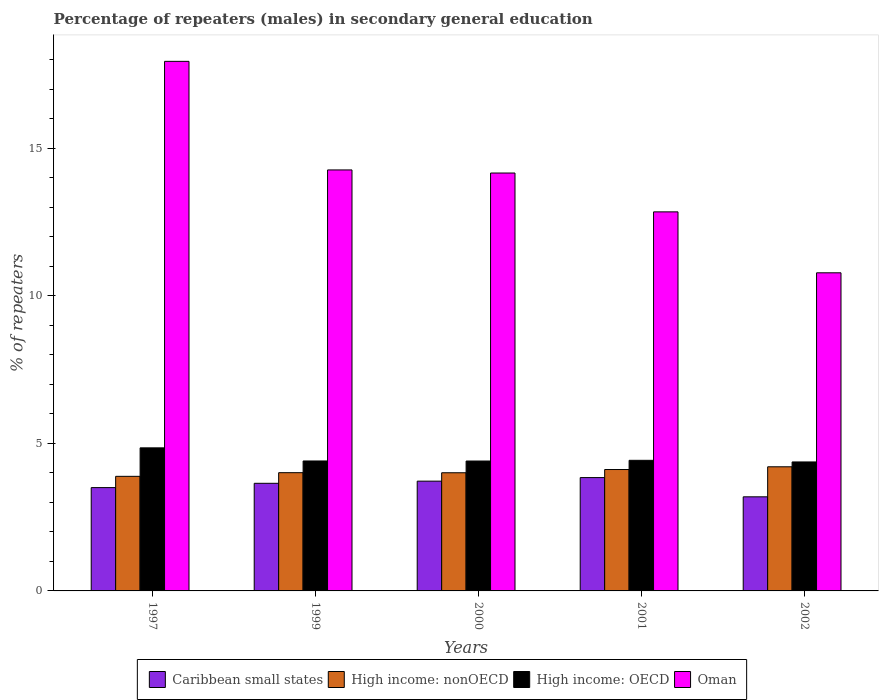How many groups of bars are there?
Your response must be concise. 5. What is the percentage of male repeaters in High income: OECD in 1999?
Your response must be concise. 4.4. Across all years, what is the maximum percentage of male repeaters in High income: nonOECD?
Provide a short and direct response. 4.21. Across all years, what is the minimum percentage of male repeaters in High income: nonOECD?
Offer a very short reply. 3.88. In which year was the percentage of male repeaters in Caribbean small states maximum?
Offer a very short reply. 2001. In which year was the percentage of male repeaters in High income: OECD minimum?
Ensure brevity in your answer.  2002. What is the total percentage of male repeaters in High income: nonOECD in the graph?
Your response must be concise. 20.22. What is the difference between the percentage of male repeaters in Oman in 2000 and that in 2002?
Make the answer very short. 3.38. What is the difference between the percentage of male repeaters in Caribbean small states in 2000 and the percentage of male repeaters in Oman in 2001?
Ensure brevity in your answer.  -9.13. What is the average percentage of male repeaters in High income: OECD per year?
Give a very brief answer. 4.49. In the year 2000, what is the difference between the percentage of male repeaters in High income: OECD and percentage of male repeaters in Caribbean small states?
Your answer should be very brief. 0.68. What is the ratio of the percentage of male repeaters in Caribbean small states in 1997 to that in 2000?
Your answer should be compact. 0.94. Is the percentage of male repeaters in Oman in 2000 less than that in 2001?
Offer a very short reply. No. What is the difference between the highest and the second highest percentage of male repeaters in High income: nonOECD?
Your answer should be compact. 0.09. What is the difference between the highest and the lowest percentage of male repeaters in High income: OECD?
Offer a very short reply. 0.48. In how many years, is the percentage of male repeaters in High income: OECD greater than the average percentage of male repeaters in High income: OECD taken over all years?
Provide a succinct answer. 1. Is the sum of the percentage of male repeaters in Caribbean small states in 1999 and 2001 greater than the maximum percentage of male repeaters in High income: OECD across all years?
Your answer should be very brief. Yes. What does the 4th bar from the left in 2000 represents?
Give a very brief answer. Oman. What does the 3rd bar from the right in 2002 represents?
Provide a short and direct response. High income: nonOECD. Are all the bars in the graph horizontal?
Provide a succinct answer. No. How many years are there in the graph?
Make the answer very short. 5. What is the difference between two consecutive major ticks on the Y-axis?
Ensure brevity in your answer.  5. Does the graph contain any zero values?
Offer a terse response. No. Where does the legend appear in the graph?
Give a very brief answer. Bottom center. How are the legend labels stacked?
Offer a terse response. Horizontal. What is the title of the graph?
Ensure brevity in your answer.  Percentage of repeaters (males) in secondary general education. What is the label or title of the Y-axis?
Ensure brevity in your answer.  % of repeaters. What is the % of repeaters in Caribbean small states in 1997?
Provide a succinct answer. 3.5. What is the % of repeaters of High income: nonOECD in 1997?
Your answer should be compact. 3.88. What is the % of repeaters of High income: OECD in 1997?
Ensure brevity in your answer.  4.85. What is the % of repeaters of Oman in 1997?
Keep it short and to the point. 17.95. What is the % of repeaters in Caribbean small states in 1999?
Your response must be concise. 3.65. What is the % of repeaters of High income: nonOECD in 1999?
Provide a short and direct response. 4.01. What is the % of repeaters of High income: OECD in 1999?
Keep it short and to the point. 4.4. What is the % of repeaters in Oman in 1999?
Your answer should be very brief. 14.27. What is the % of repeaters in Caribbean small states in 2000?
Your answer should be compact. 3.72. What is the % of repeaters of High income: nonOECD in 2000?
Your response must be concise. 4. What is the % of repeaters of High income: OECD in 2000?
Offer a terse response. 4.4. What is the % of repeaters of Oman in 2000?
Provide a succinct answer. 14.16. What is the % of repeaters of Caribbean small states in 2001?
Give a very brief answer. 3.84. What is the % of repeaters in High income: nonOECD in 2001?
Make the answer very short. 4.11. What is the % of repeaters of High income: OECD in 2001?
Give a very brief answer. 4.43. What is the % of repeaters of Oman in 2001?
Give a very brief answer. 12.85. What is the % of repeaters of Caribbean small states in 2002?
Your answer should be compact. 3.19. What is the % of repeaters in High income: nonOECD in 2002?
Give a very brief answer. 4.21. What is the % of repeaters in High income: OECD in 2002?
Offer a very short reply. 4.37. What is the % of repeaters of Oman in 2002?
Ensure brevity in your answer.  10.78. Across all years, what is the maximum % of repeaters of Caribbean small states?
Your answer should be very brief. 3.84. Across all years, what is the maximum % of repeaters of High income: nonOECD?
Give a very brief answer. 4.21. Across all years, what is the maximum % of repeaters of High income: OECD?
Give a very brief answer. 4.85. Across all years, what is the maximum % of repeaters in Oman?
Provide a short and direct response. 17.95. Across all years, what is the minimum % of repeaters in Caribbean small states?
Your response must be concise. 3.19. Across all years, what is the minimum % of repeaters of High income: nonOECD?
Make the answer very short. 3.88. Across all years, what is the minimum % of repeaters in High income: OECD?
Offer a very short reply. 4.37. Across all years, what is the minimum % of repeaters in Oman?
Offer a very short reply. 10.78. What is the total % of repeaters of Caribbean small states in the graph?
Make the answer very short. 17.9. What is the total % of repeaters in High income: nonOECD in the graph?
Ensure brevity in your answer.  20.21. What is the total % of repeaters of High income: OECD in the graph?
Your answer should be compact. 22.45. What is the total % of repeaters in Oman in the graph?
Offer a very short reply. 70. What is the difference between the % of repeaters in Caribbean small states in 1997 and that in 1999?
Keep it short and to the point. -0.15. What is the difference between the % of repeaters in High income: nonOECD in 1997 and that in 1999?
Your response must be concise. -0.12. What is the difference between the % of repeaters of High income: OECD in 1997 and that in 1999?
Ensure brevity in your answer.  0.44. What is the difference between the % of repeaters of Oman in 1997 and that in 1999?
Offer a terse response. 3.68. What is the difference between the % of repeaters in Caribbean small states in 1997 and that in 2000?
Your answer should be very brief. -0.22. What is the difference between the % of repeaters of High income: nonOECD in 1997 and that in 2000?
Your response must be concise. -0.12. What is the difference between the % of repeaters in High income: OECD in 1997 and that in 2000?
Keep it short and to the point. 0.45. What is the difference between the % of repeaters in Oman in 1997 and that in 2000?
Your response must be concise. 3.78. What is the difference between the % of repeaters in Caribbean small states in 1997 and that in 2001?
Make the answer very short. -0.34. What is the difference between the % of repeaters of High income: nonOECD in 1997 and that in 2001?
Provide a short and direct response. -0.23. What is the difference between the % of repeaters in High income: OECD in 1997 and that in 2001?
Provide a succinct answer. 0.42. What is the difference between the % of repeaters of Oman in 1997 and that in 2001?
Provide a short and direct response. 5.1. What is the difference between the % of repeaters in Caribbean small states in 1997 and that in 2002?
Keep it short and to the point. 0.31. What is the difference between the % of repeaters in High income: nonOECD in 1997 and that in 2002?
Ensure brevity in your answer.  -0.32. What is the difference between the % of repeaters of High income: OECD in 1997 and that in 2002?
Give a very brief answer. 0.48. What is the difference between the % of repeaters of Oman in 1997 and that in 2002?
Provide a short and direct response. 7.17. What is the difference between the % of repeaters in Caribbean small states in 1999 and that in 2000?
Your response must be concise. -0.07. What is the difference between the % of repeaters of High income: nonOECD in 1999 and that in 2000?
Make the answer very short. 0. What is the difference between the % of repeaters of High income: OECD in 1999 and that in 2000?
Offer a terse response. 0. What is the difference between the % of repeaters of Oman in 1999 and that in 2000?
Make the answer very short. 0.11. What is the difference between the % of repeaters in Caribbean small states in 1999 and that in 2001?
Your answer should be very brief. -0.19. What is the difference between the % of repeaters in High income: nonOECD in 1999 and that in 2001?
Make the answer very short. -0.11. What is the difference between the % of repeaters of High income: OECD in 1999 and that in 2001?
Your response must be concise. -0.02. What is the difference between the % of repeaters of Oman in 1999 and that in 2001?
Offer a very short reply. 1.42. What is the difference between the % of repeaters in Caribbean small states in 1999 and that in 2002?
Your answer should be compact. 0.46. What is the difference between the % of repeaters in High income: nonOECD in 1999 and that in 2002?
Provide a short and direct response. -0.2. What is the difference between the % of repeaters in High income: OECD in 1999 and that in 2002?
Ensure brevity in your answer.  0.03. What is the difference between the % of repeaters in Oman in 1999 and that in 2002?
Ensure brevity in your answer.  3.49. What is the difference between the % of repeaters of Caribbean small states in 2000 and that in 2001?
Your response must be concise. -0.12. What is the difference between the % of repeaters of High income: nonOECD in 2000 and that in 2001?
Give a very brief answer. -0.11. What is the difference between the % of repeaters of High income: OECD in 2000 and that in 2001?
Your answer should be compact. -0.02. What is the difference between the % of repeaters in Oman in 2000 and that in 2001?
Keep it short and to the point. 1.32. What is the difference between the % of repeaters of Caribbean small states in 2000 and that in 2002?
Offer a terse response. 0.53. What is the difference between the % of repeaters of High income: nonOECD in 2000 and that in 2002?
Keep it short and to the point. -0.2. What is the difference between the % of repeaters in High income: OECD in 2000 and that in 2002?
Ensure brevity in your answer.  0.03. What is the difference between the % of repeaters of Oman in 2000 and that in 2002?
Provide a short and direct response. 3.38. What is the difference between the % of repeaters in Caribbean small states in 2001 and that in 2002?
Make the answer very short. 0.65. What is the difference between the % of repeaters of High income: nonOECD in 2001 and that in 2002?
Provide a succinct answer. -0.09. What is the difference between the % of repeaters in High income: OECD in 2001 and that in 2002?
Your answer should be very brief. 0.05. What is the difference between the % of repeaters of Oman in 2001 and that in 2002?
Give a very brief answer. 2.07. What is the difference between the % of repeaters of Caribbean small states in 1997 and the % of repeaters of High income: nonOECD in 1999?
Ensure brevity in your answer.  -0.51. What is the difference between the % of repeaters of Caribbean small states in 1997 and the % of repeaters of High income: OECD in 1999?
Offer a very short reply. -0.9. What is the difference between the % of repeaters in Caribbean small states in 1997 and the % of repeaters in Oman in 1999?
Make the answer very short. -10.77. What is the difference between the % of repeaters of High income: nonOECD in 1997 and the % of repeaters of High income: OECD in 1999?
Your response must be concise. -0.52. What is the difference between the % of repeaters in High income: nonOECD in 1997 and the % of repeaters in Oman in 1999?
Your answer should be very brief. -10.38. What is the difference between the % of repeaters of High income: OECD in 1997 and the % of repeaters of Oman in 1999?
Ensure brevity in your answer.  -9.42. What is the difference between the % of repeaters in Caribbean small states in 1997 and the % of repeaters in High income: nonOECD in 2000?
Your answer should be compact. -0.5. What is the difference between the % of repeaters of Caribbean small states in 1997 and the % of repeaters of High income: OECD in 2000?
Give a very brief answer. -0.9. What is the difference between the % of repeaters of Caribbean small states in 1997 and the % of repeaters of Oman in 2000?
Provide a succinct answer. -10.66. What is the difference between the % of repeaters in High income: nonOECD in 1997 and the % of repeaters in High income: OECD in 2000?
Offer a terse response. -0.52. What is the difference between the % of repeaters in High income: nonOECD in 1997 and the % of repeaters in Oman in 2000?
Keep it short and to the point. -10.28. What is the difference between the % of repeaters in High income: OECD in 1997 and the % of repeaters in Oman in 2000?
Keep it short and to the point. -9.31. What is the difference between the % of repeaters in Caribbean small states in 1997 and the % of repeaters in High income: nonOECD in 2001?
Make the answer very short. -0.61. What is the difference between the % of repeaters of Caribbean small states in 1997 and the % of repeaters of High income: OECD in 2001?
Your answer should be compact. -0.92. What is the difference between the % of repeaters of Caribbean small states in 1997 and the % of repeaters of Oman in 2001?
Offer a very short reply. -9.34. What is the difference between the % of repeaters in High income: nonOECD in 1997 and the % of repeaters in High income: OECD in 2001?
Offer a terse response. -0.54. What is the difference between the % of repeaters in High income: nonOECD in 1997 and the % of repeaters in Oman in 2001?
Ensure brevity in your answer.  -8.96. What is the difference between the % of repeaters of High income: OECD in 1997 and the % of repeaters of Oman in 2001?
Your response must be concise. -8. What is the difference between the % of repeaters of Caribbean small states in 1997 and the % of repeaters of High income: nonOECD in 2002?
Make the answer very short. -0.71. What is the difference between the % of repeaters in Caribbean small states in 1997 and the % of repeaters in High income: OECD in 2002?
Your answer should be very brief. -0.87. What is the difference between the % of repeaters in Caribbean small states in 1997 and the % of repeaters in Oman in 2002?
Offer a terse response. -7.28. What is the difference between the % of repeaters of High income: nonOECD in 1997 and the % of repeaters of High income: OECD in 2002?
Keep it short and to the point. -0.49. What is the difference between the % of repeaters of High income: nonOECD in 1997 and the % of repeaters of Oman in 2002?
Provide a short and direct response. -6.9. What is the difference between the % of repeaters in High income: OECD in 1997 and the % of repeaters in Oman in 2002?
Your answer should be compact. -5.93. What is the difference between the % of repeaters of Caribbean small states in 1999 and the % of repeaters of High income: nonOECD in 2000?
Keep it short and to the point. -0.36. What is the difference between the % of repeaters in Caribbean small states in 1999 and the % of repeaters in High income: OECD in 2000?
Your response must be concise. -0.75. What is the difference between the % of repeaters of Caribbean small states in 1999 and the % of repeaters of Oman in 2000?
Your answer should be compact. -10.51. What is the difference between the % of repeaters in High income: nonOECD in 1999 and the % of repeaters in High income: OECD in 2000?
Your response must be concise. -0.4. What is the difference between the % of repeaters in High income: nonOECD in 1999 and the % of repeaters in Oman in 2000?
Ensure brevity in your answer.  -10.16. What is the difference between the % of repeaters of High income: OECD in 1999 and the % of repeaters of Oman in 2000?
Your answer should be compact. -9.76. What is the difference between the % of repeaters of Caribbean small states in 1999 and the % of repeaters of High income: nonOECD in 2001?
Give a very brief answer. -0.47. What is the difference between the % of repeaters in Caribbean small states in 1999 and the % of repeaters in High income: OECD in 2001?
Make the answer very short. -0.78. What is the difference between the % of repeaters of Caribbean small states in 1999 and the % of repeaters of Oman in 2001?
Your answer should be compact. -9.2. What is the difference between the % of repeaters in High income: nonOECD in 1999 and the % of repeaters in High income: OECD in 2001?
Your response must be concise. -0.42. What is the difference between the % of repeaters in High income: nonOECD in 1999 and the % of repeaters in Oman in 2001?
Your answer should be compact. -8.84. What is the difference between the % of repeaters of High income: OECD in 1999 and the % of repeaters of Oman in 2001?
Keep it short and to the point. -8.44. What is the difference between the % of repeaters in Caribbean small states in 1999 and the % of repeaters in High income: nonOECD in 2002?
Ensure brevity in your answer.  -0.56. What is the difference between the % of repeaters in Caribbean small states in 1999 and the % of repeaters in High income: OECD in 2002?
Provide a short and direct response. -0.72. What is the difference between the % of repeaters of Caribbean small states in 1999 and the % of repeaters of Oman in 2002?
Offer a very short reply. -7.13. What is the difference between the % of repeaters of High income: nonOECD in 1999 and the % of repeaters of High income: OECD in 2002?
Offer a terse response. -0.36. What is the difference between the % of repeaters of High income: nonOECD in 1999 and the % of repeaters of Oman in 2002?
Your answer should be very brief. -6.77. What is the difference between the % of repeaters in High income: OECD in 1999 and the % of repeaters in Oman in 2002?
Keep it short and to the point. -6.38. What is the difference between the % of repeaters of Caribbean small states in 2000 and the % of repeaters of High income: nonOECD in 2001?
Ensure brevity in your answer.  -0.39. What is the difference between the % of repeaters of Caribbean small states in 2000 and the % of repeaters of High income: OECD in 2001?
Ensure brevity in your answer.  -0.71. What is the difference between the % of repeaters in Caribbean small states in 2000 and the % of repeaters in Oman in 2001?
Give a very brief answer. -9.13. What is the difference between the % of repeaters of High income: nonOECD in 2000 and the % of repeaters of High income: OECD in 2001?
Keep it short and to the point. -0.42. What is the difference between the % of repeaters in High income: nonOECD in 2000 and the % of repeaters in Oman in 2001?
Offer a very short reply. -8.84. What is the difference between the % of repeaters of High income: OECD in 2000 and the % of repeaters of Oman in 2001?
Keep it short and to the point. -8.44. What is the difference between the % of repeaters of Caribbean small states in 2000 and the % of repeaters of High income: nonOECD in 2002?
Provide a succinct answer. -0.49. What is the difference between the % of repeaters of Caribbean small states in 2000 and the % of repeaters of High income: OECD in 2002?
Give a very brief answer. -0.65. What is the difference between the % of repeaters in Caribbean small states in 2000 and the % of repeaters in Oman in 2002?
Provide a succinct answer. -7.06. What is the difference between the % of repeaters of High income: nonOECD in 2000 and the % of repeaters of High income: OECD in 2002?
Keep it short and to the point. -0.37. What is the difference between the % of repeaters of High income: nonOECD in 2000 and the % of repeaters of Oman in 2002?
Ensure brevity in your answer.  -6.78. What is the difference between the % of repeaters of High income: OECD in 2000 and the % of repeaters of Oman in 2002?
Provide a short and direct response. -6.38. What is the difference between the % of repeaters in Caribbean small states in 2001 and the % of repeaters in High income: nonOECD in 2002?
Your answer should be very brief. -0.37. What is the difference between the % of repeaters of Caribbean small states in 2001 and the % of repeaters of High income: OECD in 2002?
Provide a short and direct response. -0.53. What is the difference between the % of repeaters of Caribbean small states in 2001 and the % of repeaters of Oman in 2002?
Offer a terse response. -6.94. What is the difference between the % of repeaters in High income: nonOECD in 2001 and the % of repeaters in High income: OECD in 2002?
Your response must be concise. -0.26. What is the difference between the % of repeaters of High income: nonOECD in 2001 and the % of repeaters of Oman in 2002?
Your answer should be very brief. -6.67. What is the difference between the % of repeaters of High income: OECD in 2001 and the % of repeaters of Oman in 2002?
Offer a very short reply. -6.35. What is the average % of repeaters in Caribbean small states per year?
Provide a short and direct response. 3.58. What is the average % of repeaters of High income: nonOECD per year?
Offer a terse response. 4.04. What is the average % of repeaters of High income: OECD per year?
Provide a succinct answer. 4.49. What is the average % of repeaters in Oman per year?
Provide a succinct answer. 14. In the year 1997, what is the difference between the % of repeaters of Caribbean small states and % of repeaters of High income: nonOECD?
Provide a short and direct response. -0.38. In the year 1997, what is the difference between the % of repeaters of Caribbean small states and % of repeaters of High income: OECD?
Your answer should be very brief. -1.35. In the year 1997, what is the difference between the % of repeaters in Caribbean small states and % of repeaters in Oman?
Offer a terse response. -14.45. In the year 1997, what is the difference between the % of repeaters in High income: nonOECD and % of repeaters in High income: OECD?
Provide a short and direct response. -0.97. In the year 1997, what is the difference between the % of repeaters in High income: nonOECD and % of repeaters in Oman?
Make the answer very short. -14.06. In the year 1997, what is the difference between the % of repeaters in High income: OECD and % of repeaters in Oman?
Keep it short and to the point. -13.1. In the year 1999, what is the difference between the % of repeaters of Caribbean small states and % of repeaters of High income: nonOECD?
Your answer should be very brief. -0.36. In the year 1999, what is the difference between the % of repeaters of Caribbean small states and % of repeaters of High income: OECD?
Keep it short and to the point. -0.76. In the year 1999, what is the difference between the % of repeaters of Caribbean small states and % of repeaters of Oman?
Make the answer very short. -10.62. In the year 1999, what is the difference between the % of repeaters of High income: nonOECD and % of repeaters of High income: OECD?
Provide a short and direct response. -0.4. In the year 1999, what is the difference between the % of repeaters of High income: nonOECD and % of repeaters of Oman?
Ensure brevity in your answer.  -10.26. In the year 1999, what is the difference between the % of repeaters of High income: OECD and % of repeaters of Oman?
Keep it short and to the point. -9.86. In the year 2000, what is the difference between the % of repeaters in Caribbean small states and % of repeaters in High income: nonOECD?
Provide a succinct answer. -0.28. In the year 2000, what is the difference between the % of repeaters of Caribbean small states and % of repeaters of High income: OECD?
Provide a short and direct response. -0.68. In the year 2000, what is the difference between the % of repeaters in Caribbean small states and % of repeaters in Oman?
Provide a short and direct response. -10.44. In the year 2000, what is the difference between the % of repeaters in High income: nonOECD and % of repeaters in High income: OECD?
Give a very brief answer. -0.4. In the year 2000, what is the difference between the % of repeaters in High income: nonOECD and % of repeaters in Oman?
Provide a succinct answer. -10.16. In the year 2000, what is the difference between the % of repeaters in High income: OECD and % of repeaters in Oman?
Offer a terse response. -9.76. In the year 2001, what is the difference between the % of repeaters of Caribbean small states and % of repeaters of High income: nonOECD?
Ensure brevity in your answer.  -0.27. In the year 2001, what is the difference between the % of repeaters in Caribbean small states and % of repeaters in High income: OECD?
Offer a terse response. -0.58. In the year 2001, what is the difference between the % of repeaters of Caribbean small states and % of repeaters of Oman?
Your response must be concise. -9.01. In the year 2001, what is the difference between the % of repeaters of High income: nonOECD and % of repeaters of High income: OECD?
Provide a succinct answer. -0.31. In the year 2001, what is the difference between the % of repeaters of High income: nonOECD and % of repeaters of Oman?
Keep it short and to the point. -8.73. In the year 2001, what is the difference between the % of repeaters in High income: OECD and % of repeaters in Oman?
Provide a succinct answer. -8.42. In the year 2002, what is the difference between the % of repeaters of Caribbean small states and % of repeaters of High income: nonOECD?
Offer a very short reply. -1.02. In the year 2002, what is the difference between the % of repeaters of Caribbean small states and % of repeaters of High income: OECD?
Your response must be concise. -1.18. In the year 2002, what is the difference between the % of repeaters in Caribbean small states and % of repeaters in Oman?
Your answer should be very brief. -7.59. In the year 2002, what is the difference between the % of repeaters of High income: nonOECD and % of repeaters of High income: OECD?
Offer a very short reply. -0.16. In the year 2002, what is the difference between the % of repeaters in High income: nonOECD and % of repeaters in Oman?
Your answer should be compact. -6.57. In the year 2002, what is the difference between the % of repeaters in High income: OECD and % of repeaters in Oman?
Give a very brief answer. -6.41. What is the ratio of the % of repeaters of High income: nonOECD in 1997 to that in 1999?
Keep it short and to the point. 0.97. What is the ratio of the % of repeaters in High income: OECD in 1997 to that in 1999?
Ensure brevity in your answer.  1.1. What is the ratio of the % of repeaters of Oman in 1997 to that in 1999?
Your response must be concise. 1.26. What is the ratio of the % of repeaters in Caribbean small states in 1997 to that in 2000?
Make the answer very short. 0.94. What is the ratio of the % of repeaters of High income: nonOECD in 1997 to that in 2000?
Offer a very short reply. 0.97. What is the ratio of the % of repeaters in High income: OECD in 1997 to that in 2000?
Offer a terse response. 1.1. What is the ratio of the % of repeaters of Oman in 1997 to that in 2000?
Ensure brevity in your answer.  1.27. What is the ratio of the % of repeaters of Caribbean small states in 1997 to that in 2001?
Provide a succinct answer. 0.91. What is the ratio of the % of repeaters of High income: nonOECD in 1997 to that in 2001?
Make the answer very short. 0.94. What is the ratio of the % of repeaters of High income: OECD in 1997 to that in 2001?
Make the answer very short. 1.1. What is the ratio of the % of repeaters in Oman in 1997 to that in 2001?
Offer a terse response. 1.4. What is the ratio of the % of repeaters in Caribbean small states in 1997 to that in 2002?
Make the answer very short. 1.1. What is the ratio of the % of repeaters in High income: nonOECD in 1997 to that in 2002?
Your response must be concise. 0.92. What is the ratio of the % of repeaters in High income: OECD in 1997 to that in 2002?
Offer a terse response. 1.11. What is the ratio of the % of repeaters in Oman in 1997 to that in 2002?
Make the answer very short. 1.66. What is the ratio of the % of repeaters of Caribbean small states in 1999 to that in 2000?
Your answer should be very brief. 0.98. What is the ratio of the % of repeaters in High income: OECD in 1999 to that in 2000?
Offer a very short reply. 1. What is the ratio of the % of repeaters of Oman in 1999 to that in 2000?
Provide a succinct answer. 1.01. What is the ratio of the % of repeaters of Caribbean small states in 1999 to that in 2001?
Your answer should be compact. 0.95. What is the ratio of the % of repeaters in Oman in 1999 to that in 2001?
Make the answer very short. 1.11. What is the ratio of the % of repeaters in Caribbean small states in 1999 to that in 2002?
Give a very brief answer. 1.14. What is the ratio of the % of repeaters in High income: nonOECD in 1999 to that in 2002?
Give a very brief answer. 0.95. What is the ratio of the % of repeaters of High income: OECD in 1999 to that in 2002?
Make the answer very short. 1.01. What is the ratio of the % of repeaters of Oman in 1999 to that in 2002?
Provide a short and direct response. 1.32. What is the ratio of the % of repeaters in Caribbean small states in 2000 to that in 2001?
Ensure brevity in your answer.  0.97. What is the ratio of the % of repeaters of High income: nonOECD in 2000 to that in 2001?
Provide a succinct answer. 0.97. What is the ratio of the % of repeaters in Oman in 2000 to that in 2001?
Give a very brief answer. 1.1. What is the ratio of the % of repeaters of Caribbean small states in 2000 to that in 2002?
Your answer should be compact. 1.17. What is the ratio of the % of repeaters of High income: nonOECD in 2000 to that in 2002?
Your response must be concise. 0.95. What is the ratio of the % of repeaters of High income: OECD in 2000 to that in 2002?
Your answer should be very brief. 1.01. What is the ratio of the % of repeaters of Oman in 2000 to that in 2002?
Make the answer very short. 1.31. What is the ratio of the % of repeaters of Caribbean small states in 2001 to that in 2002?
Keep it short and to the point. 1.2. What is the ratio of the % of repeaters in High income: nonOECD in 2001 to that in 2002?
Offer a very short reply. 0.98. What is the ratio of the % of repeaters in High income: OECD in 2001 to that in 2002?
Offer a terse response. 1.01. What is the ratio of the % of repeaters of Oman in 2001 to that in 2002?
Offer a terse response. 1.19. What is the difference between the highest and the second highest % of repeaters of Caribbean small states?
Offer a terse response. 0.12. What is the difference between the highest and the second highest % of repeaters of High income: nonOECD?
Keep it short and to the point. 0.09. What is the difference between the highest and the second highest % of repeaters in High income: OECD?
Provide a succinct answer. 0.42. What is the difference between the highest and the second highest % of repeaters of Oman?
Provide a short and direct response. 3.68. What is the difference between the highest and the lowest % of repeaters in Caribbean small states?
Keep it short and to the point. 0.65. What is the difference between the highest and the lowest % of repeaters in High income: nonOECD?
Your answer should be very brief. 0.32. What is the difference between the highest and the lowest % of repeaters in High income: OECD?
Keep it short and to the point. 0.48. What is the difference between the highest and the lowest % of repeaters of Oman?
Your answer should be compact. 7.17. 